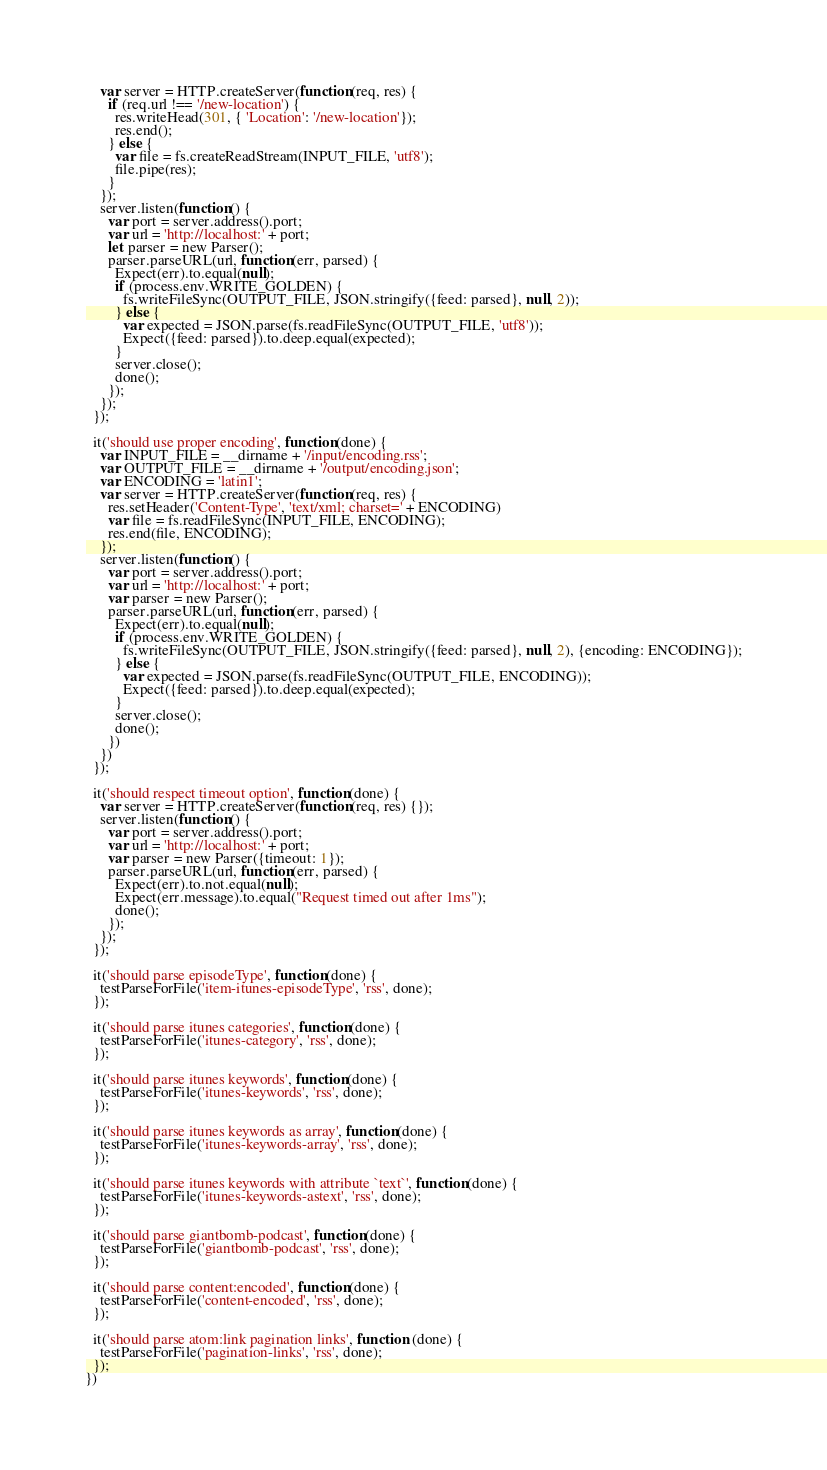<code> <loc_0><loc_0><loc_500><loc_500><_JavaScript_>    var server = HTTP.createServer(function(req, res) {
      if (req.url !== '/new-location') {
        res.writeHead(301, { 'Location': '/new-location'});
        res.end();
      } else {
        var file = fs.createReadStream(INPUT_FILE, 'utf8');
        file.pipe(res);
      }
    });
    server.listen(function() {
      var port = server.address().port;
      var url = 'http://localhost:' + port;
      let parser = new Parser();
      parser.parseURL(url, function(err, parsed) {
        Expect(err).to.equal(null);
        if (process.env.WRITE_GOLDEN) {
          fs.writeFileSync(OUTPUT_FILE, JSON.stringify({feed: parsed}, null, 2));
        } else {
          var expected = JSON.parse(fs.readFileSync(OUTPUT_FILE, 'utf8'));
          Expect({feed: parsed}).to.deep.equal(expected);
        }
        server.close();
        done();
      });
    });
  });

  it('should use proper encoding', function(done) {
    var INPUT_FILE = __dirname + '/input/encoding.rss';
    var OUTPUT_FILE = __dirname + '/output/encoding.json';
    var ENCODING = 'latin1';
    var server = HTTP.createServer(function(req, res) {
      res.setHeader('Content-Type', 'text/xml; charset=' + ENCODING)
      var file = fs.readFileSync(INPUT_FILE, ENCODING);
      res.end(file, ENCODING);
    });
    server.listen(function() {
      var port = server.address().port;
      var url = 'http://localhost:' + port;
      var parser = new Parser();
      parser.parseURL(url, function(err, parsed) {
        Expect(err).to.equal(null);
        if (process.env.WRITE_GOLDEN) {
          fs.writeFileSync(OUTPUT_FILE, JSON.stringify({feed: parsed}, null, 2), {encoding: ENCODING});
        } else {
          var expected = JSON.parse(fs.readFileSync(OUTPUT_FILE, ENCODING));
          Expect({feed: parsed}).to.deep.equal(expected);
        }
        server.close();
        done();
      })
    })
  });

  it('should respect timeout option', function(done) {
    var server = HTTP.createServer(function(req, res) {});
    server.listen(function() {
      var port = server.address().port;
      var url = 'http://localhost:' + port;
      var parser = new Parser({timeout: 1});
      parser.parseURL(url, function(err, parsed) {
        Expect(err).to.not.equal(null);
        Expect(err.message).to.equal("Request timed out after 1ms");
        done();
      });
    });
  });

  it('should parse episodeType', function(done) {
    testParseForFile('item-itunes-episodeType', 'rss', done);
  });

  it('should parse itunes categories', function(done) {
    testParseForFile('itunes-category', 'rss', done);
  });

  it('should parse itunes keywords', function(done) {
    testParseForFile('itunes-keywords', 'rss', done);
  });

  it('should parse itunes keywords as array', function(done) {
    testParseForFile('itunes-keywords-array', 'rss', done);
  });

  it('should parse itunes keywords with attribute `text`', function(done) {
    testParseForFile('itunes-keywords-astext', 'rss', done);
  });

  it('should parse giantbomb-podcast', function(done) {
    testParseForFile('giantbomb-podcast', 'rss', done);
  });

  it('should parse content:encoded', function(done) {
    testParseForFile('content-encoded', 'rss', done);
  });

  it('should parse atom:link pagination links', function (done) {
    testParseForFile('pagination-links', 'rss', done);
  });
})
</code> 